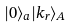Convert formula to latex. <formula><loc_0><loc_0><loc_500><loc_500>| 0 \rangle _ { a } | k _ { r } \rangle _ { A }</formula> 